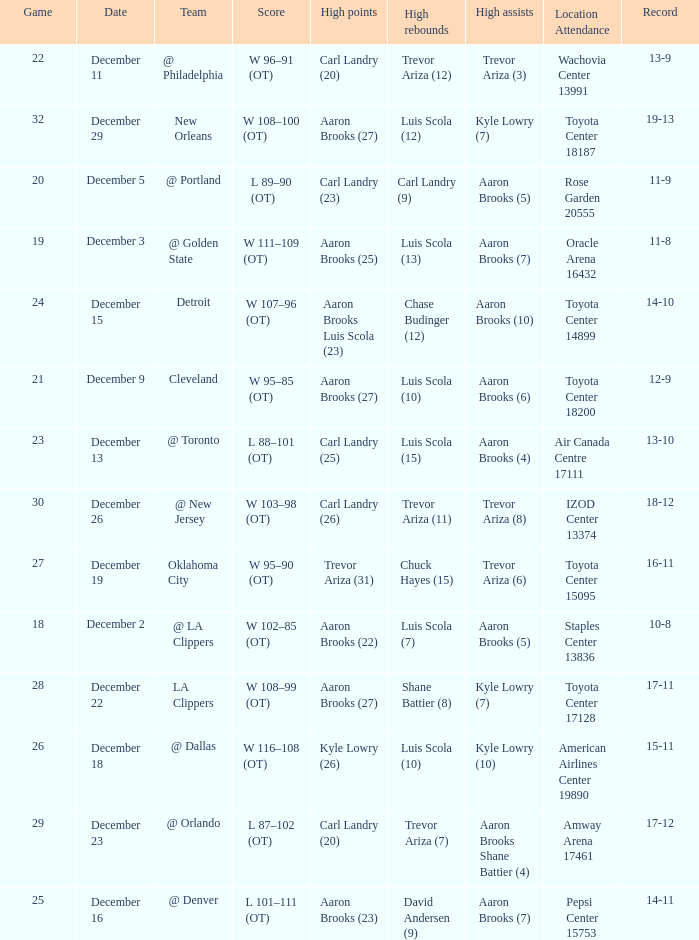Where was the game in which Carl Landry (25) did the most high points played? Air Canada Centre 17111. 